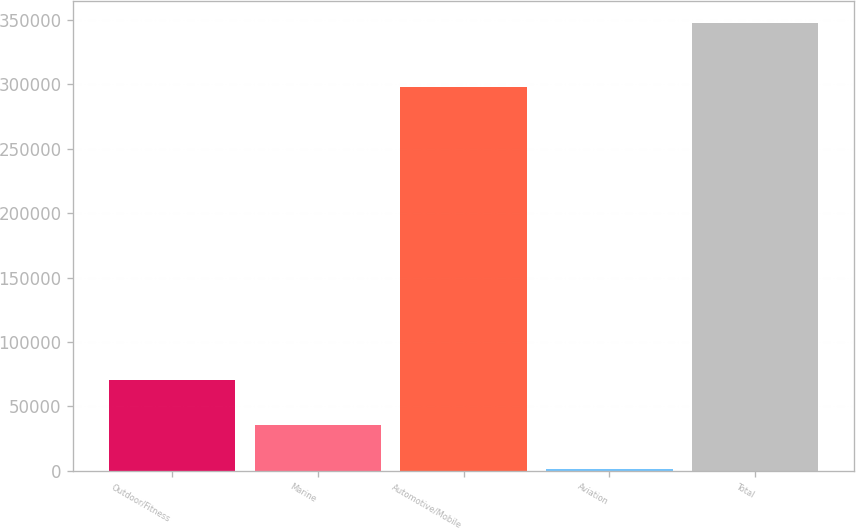Convert chart to OTSL. <chart><loc_0><loc_0><loc_500><loc_500><bar_chart><fcel>Outdoor/Fitness<fcel>Marine<fcel>Automotive/Mobile<fcel>Aviation<fcel>Total<nl><fcel>70331.2<fcel>35708.1<fcel>297553<fcel>1085<fcel>347316<nl></chart> 